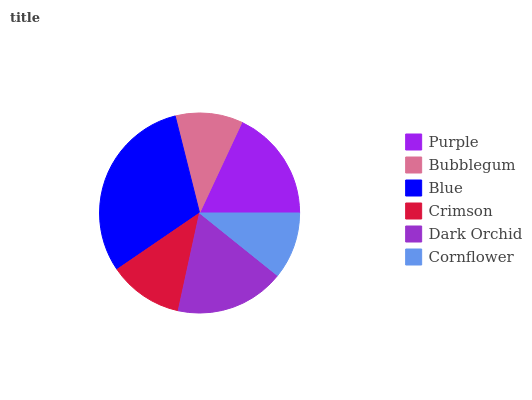Is Cornflower the minimum?
Answer yes or no. Yes. Is Blue the maximum?
Answer yes or no. Yes. Is Bubblegum the minimum?
Answer yes or no. No. Is Bubblegum the maximum?
Answer yes or no. No. Is Purple greater than Bubblegum?
Answer yes or no. Yes. Is Bubblegum less than Purple?
Answer yes or no. Yes. Is Bubblegum greater than Purple?
Answer yes or no. No. Is Purple less than Bubblegum?
Answer yes or no. No. Is Dark Orchid the high median?
Answer yes or no. Yes. Is Crimson the low median?
Answer yes or no. Yes. Is Purple the high median?
Answer yes or no. No. Is Purple the low median?
Answer yes or no. No. 